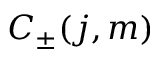<formula> <loc_0><loc_0><loc_500><loc_500>C _ { \pm } ( j , m )</formula> 